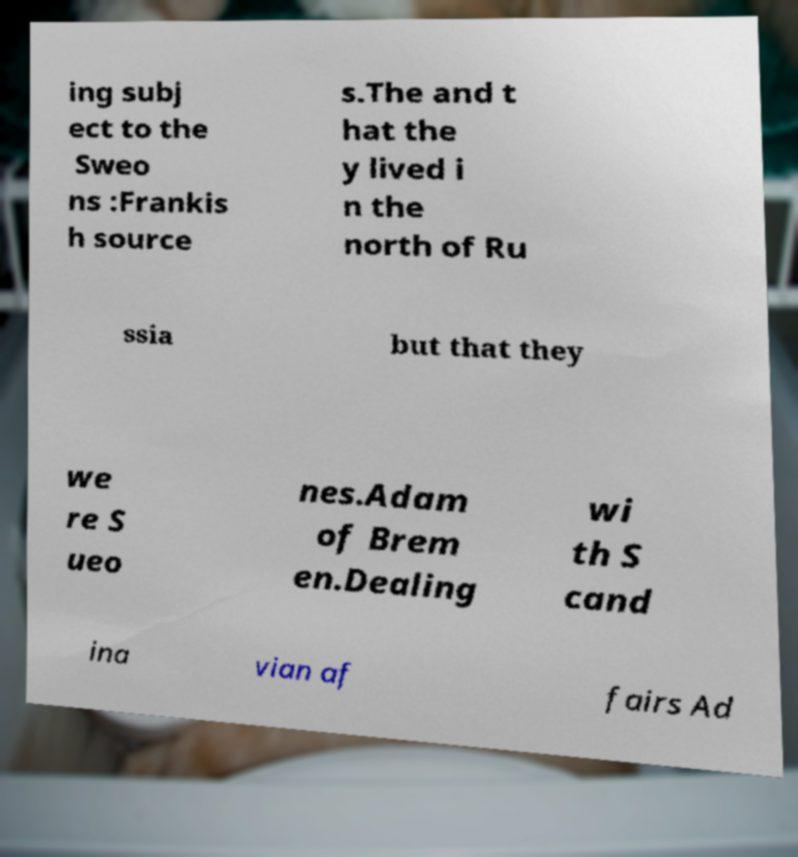Could you assist in decoding the text presented in this image and type it out clearly? ing subj ect to the Sweo ns :Frankis h source s.The and t hat the y lived i n the north of Ru ssia but that they we re S ueo nes.Adam of Brem en.Dealing wi th S cand ina vian af fairs Ad 